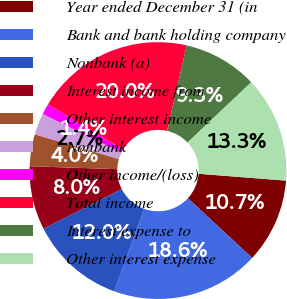Convert chart to OTSL. <chart><loc_0><loc_0><loc_500><loc_500><pie_chart><fcel>Year ended December 31 (in<fcel>Bank and bank holding company<fcel>Nonbank (a)<fcel>Interest income from<fcel>Other interest income<fcel>Nonbank<fcel>Other income/(loss)<fcel>Total income<fcel>Interest expense to<fcel>Other interest expense<nl><fcel>10.66%<fcel>18.63%<fcel>11.99%<fcel>8.01%<fcel>4.02%<fcel>2.7%<fcel>1.37%<fcel>19.96%<fcel>9.34%<fcel>13.32%<nl></chart> 